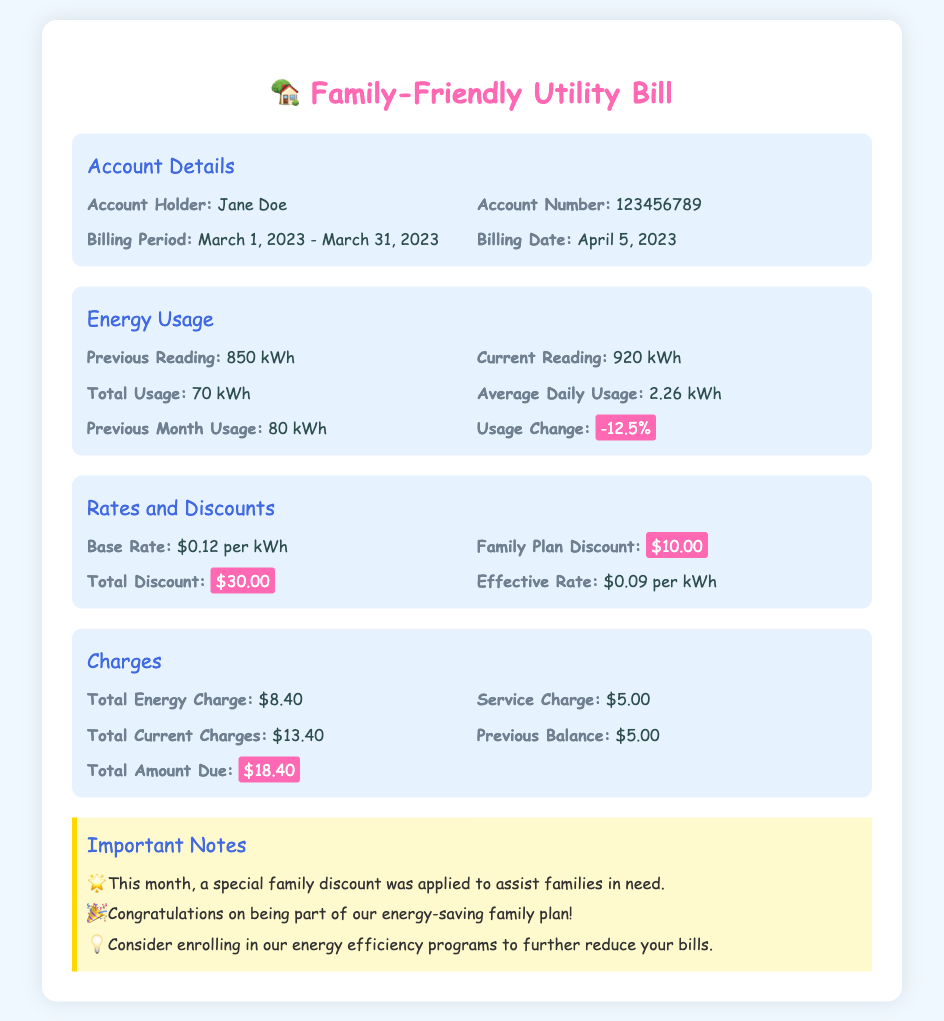What is the account holder's name? The document specifies the name of the account holder as Jane Doe.
Answer: Jane Doe What is the billing period for the utility bill? The billing period stated in the document is from March 1, 2023, to March 31, 2023.
Answer: March 1, 2023 - March 31, 2023 How much energy was used in total during March? The total energy usage is indicated as 70 kWh in the energy usage section.
Answer: 70 kWh What was the average daily energy usage? The document provides the average daily usage as 2.26 kWh.
Answer: 2.26 kWh What is the family plan discount amount? The document shows that the family plan discount is $10.00.
Answer: $10.00 What is the total amount due for the account? The total amount due as per the document is highlighted as $18.40.
Answer: $18.40 What was the previous month's usage? The previous month's energy usage is stated as 80 kWh.
Answer: 80 kWh What was the effective rate per kWh? The effective rate per kWh, after discounts, is specified as $0.09.
Answer: $0.09 What is noted about the discounts applied this month? The document notes that a special family discount was applied to assist families in need.
Answer: Special family discount applied 